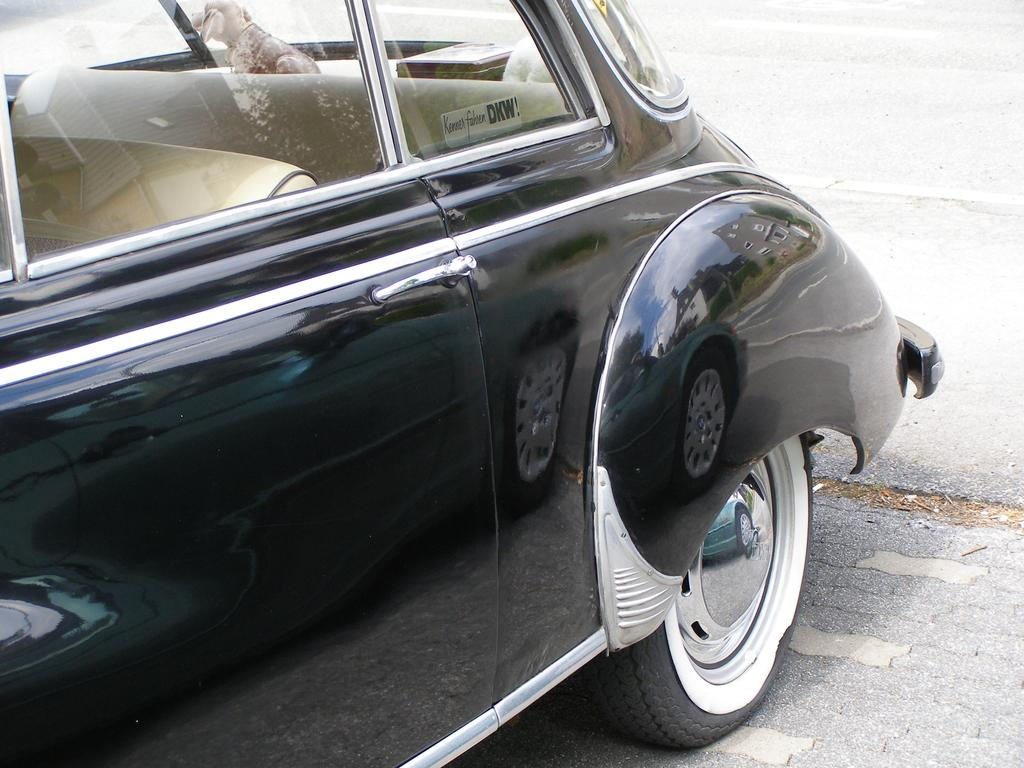What type of vehicle is in the image? There is a black car in the image. What can be seen inside the car through the glass? There is a dog visible through the glass. What is the setting for the car in the image? The bottom portion of the image contains a road. What time of day is it in the image, based on the position of the desk? There is no desk present in the image, so we cannot determine the time of day based on its position. 